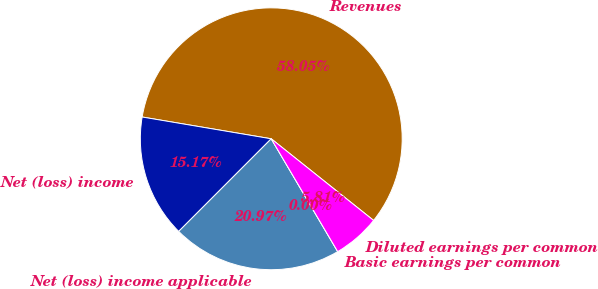<chart> <loc_0><loc_0><loc_500><loc_500><pie_chart><fcel>Revenues<fcel>Net (loss) income<fcel>Net (loss) income applicable<fcel>Basic earnings per common<fcel>Diluted earnings per common<nl><fcel>58.06%<fcel>15.17%<fcel>20.97%<fcel>0.0%<fcel>5.81%<nl></chart> 